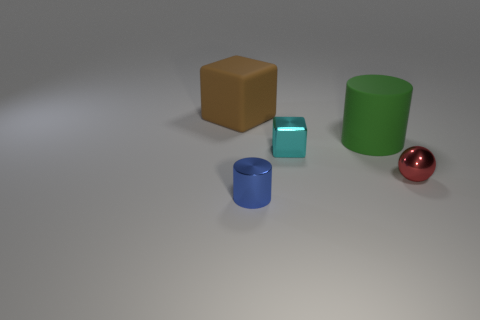How does the lighting affect the appearance of the objects? The lighting creates soft shadows and subtle reflections on the objects, enhancing their three-dimensional form. It's a diffused light source that doesn't create harsh contrasts but rather a gentle illumination that highlights the colors and shapes of the objects. 